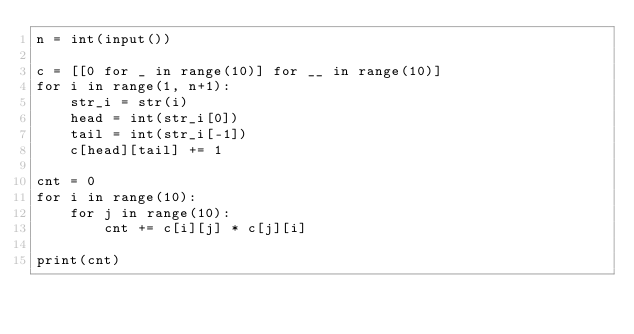Convert code to text. <code><loc_0><loc_0><loc_500><loc_500><_Python_>n = int(input())

c = [[0 for _ in range(10)] for __ in range(10)]
for i in range(1, n+1):
    str_i = str(i)
    head = int(str_i[0])
    tail = int(str_i[-1])
    c[head][tail] += 1

cnt = 0
for i in range(10):
    for j in range(10):
        cnt += c[i][j] * c[j][i]

print(cnt)</code> 